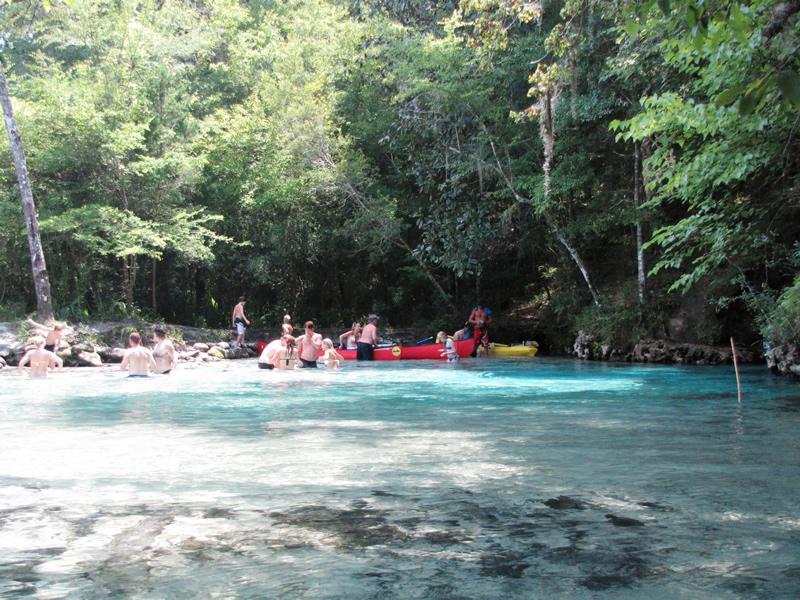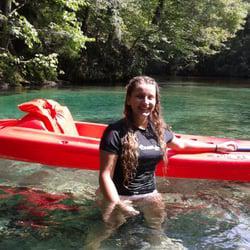The first image is the image on the left, the second image is the image on the right. Considering the images on both sides, is "There is a woman in the image on the right." valid? Answer yes or no. Yes. 